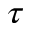Convert formula to latex. <formula><loc_0><loc_0><loc_500><loc_500>\tau</formula> 